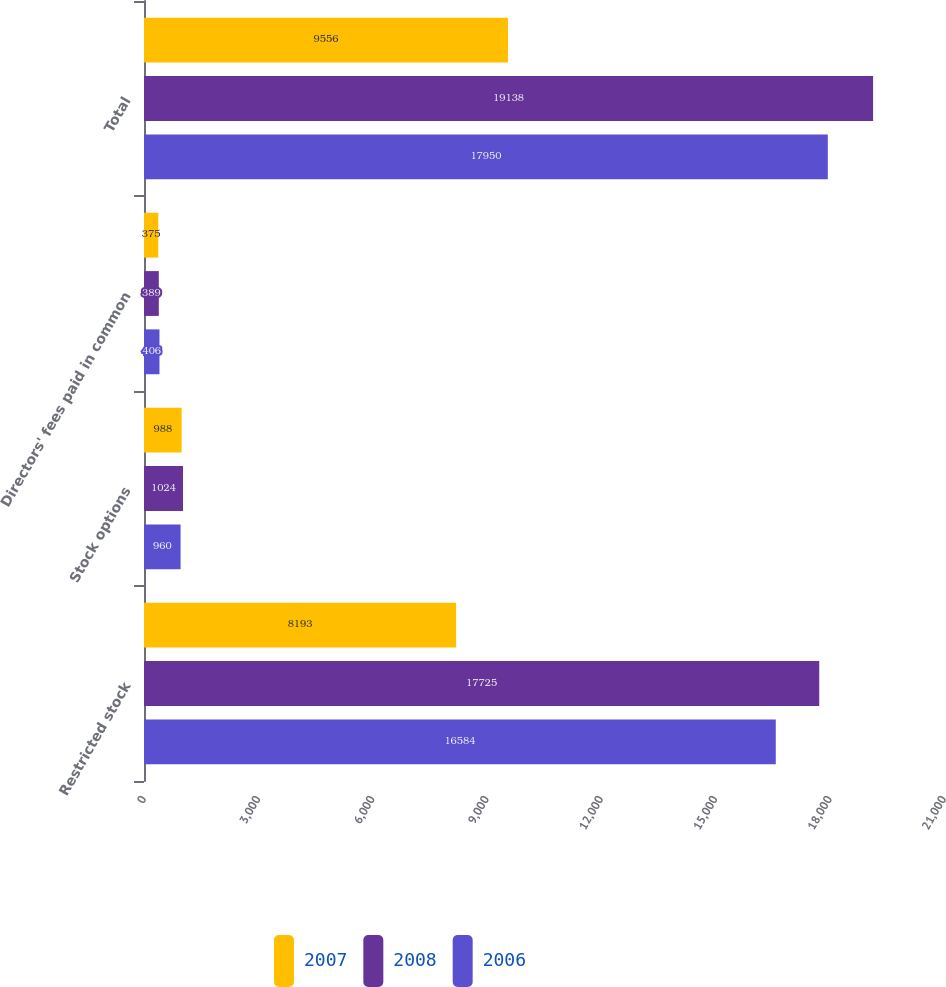<chart> <loc_0><loc_0><loc_500><loc_500><stacked_bar_chart><ecel><fcel>Restricted stock<fcel>Stock options<fcel>Directors' fees paid in common<fcel>Total<nl><fcel>2007<fcel>8193<fcel>988<fcel>375<fcel>9556<nl><fcel>2008<fcel>17725<fcel>1024<fcel>389<fcel>19138<nl><fcel>2006<fcel>16584<fcel>960<fcel>406<fcel>17950<nl></chart> 